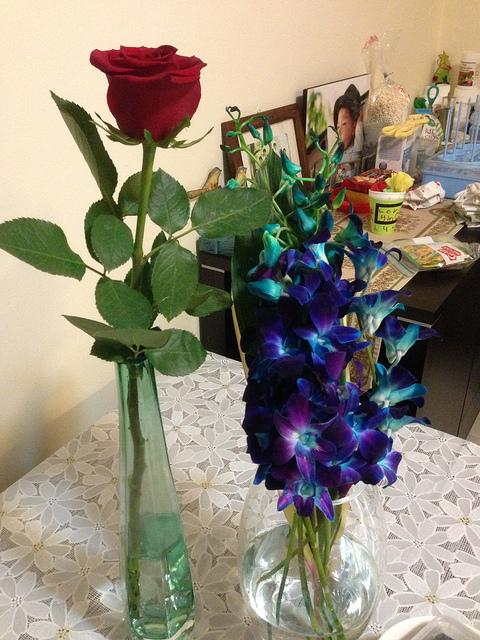What kind of flowers are these?
Keep it brief. Rose. What type of flower is red?
Quick response, please. Rose. What is the tallest flower?
Give a very brief answer. Rose. What kind of flower is the blue one?
Concise answer only. Lilac. What is in the glass?
Give a very brief answer. Flowers. 